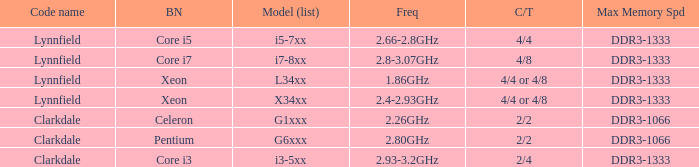What brand is model G6xxx? Pentium. 